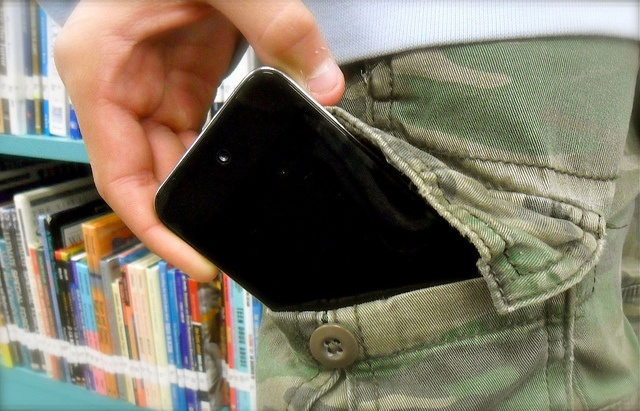Describe the objects in this image and their specific colors. I can see people in gray, darkgray, and lightgray tones, cell phone in gray, black, and white tones, book in gray, tan, beige, and darkgray tones, book in gray, olive, and darkgray tones, and book in gray, black, darkgray, and lightgray tones in this image. 